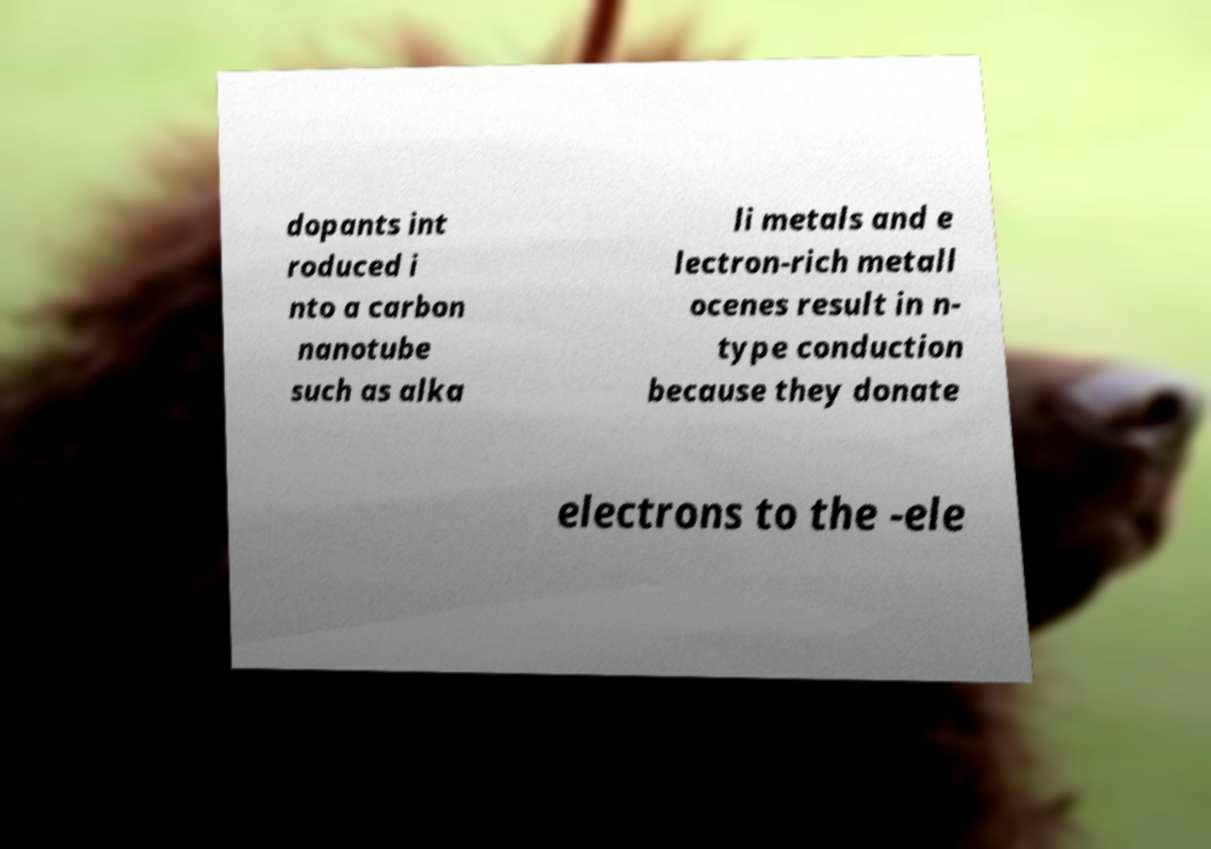Please identify and transcribe the text found in this image. dopants int roduced i nto a carbon nanotube such as alka li metals and e lectron-rich metall ocenes result in n- type conduction because they donate electrons to the -ele 